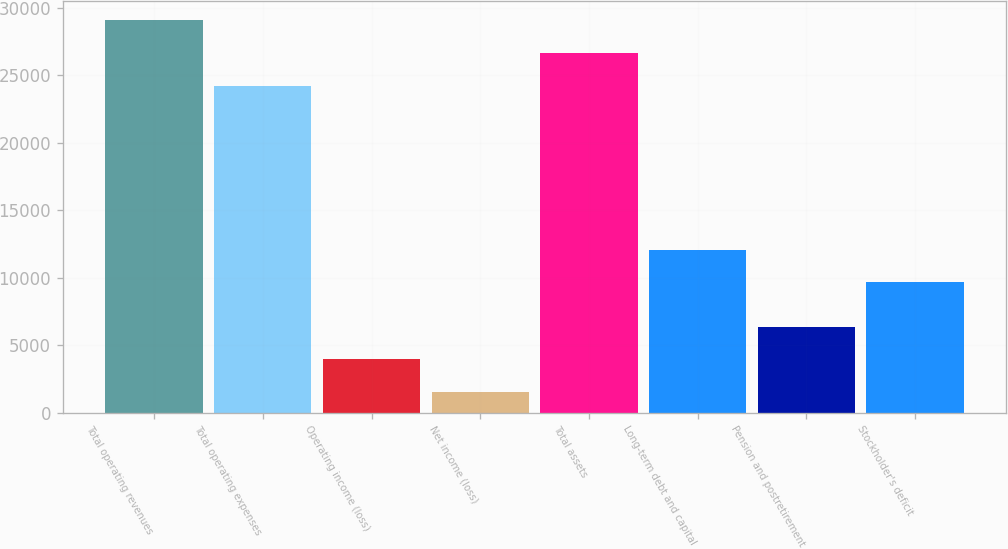Convert chart to OTSL. <chart><loc_0><loc_0><loc_500><loc_500><bar_chart><fcel>Total operating revenues<fcel>Total operating expenses<fcel>Operating income (loss)<fcel>Net income (loss)<fcel>Total assets<fcel>Long-term debt and capital<fcel>Pension and postretirement<fcel>Stockholder's deficit<nl><fcel>29072.8<fcel>24226<fcel>3949.4<fcel>1526<fcel>26649.4<fcel>12083.4<fcel>6372.8<fcel>9660<nl></chart> 